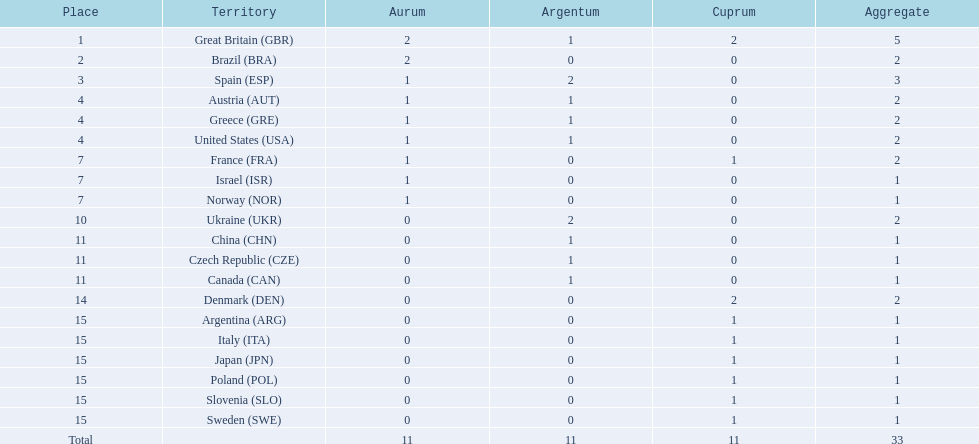What are all of the countries? Great Britain (GBR), Brazil (BRA), Spain (ESP), Austria (AUT), Greece (GRE), United States (USA), France (FRA), Israel (ISR), Norway (NOR), Ukraine (UKR), China (CHN), Czech Republic (CZE), Canada (CAN), Denmark (DEN), Argentina (ARG), Italy (ITA), Japan (JPN), Poland (POL), Slovenia (SLO), Sweden (SWE). Which ones earned a medal? Great Britain (GBR), Brazil (BRA), Spain (ESP), Austria (AUT), Greece (GRE), United States (USA), France (FRA), Israel (ISR), Norway (NOR), Ukraine (UKR), China (CHN), Czech Republic (CZE), Canada (CAN), Denmark (DEN), Argentina (ARG), Italy (ITA), Japan (JPN), Poland (POL), Slovenia (SLO), Sweden (SWE). Which countries earned at least 3 medals? Great Britain (GBR), Spain (ESP). Which country earned 3 medals? Spain (ESP). 